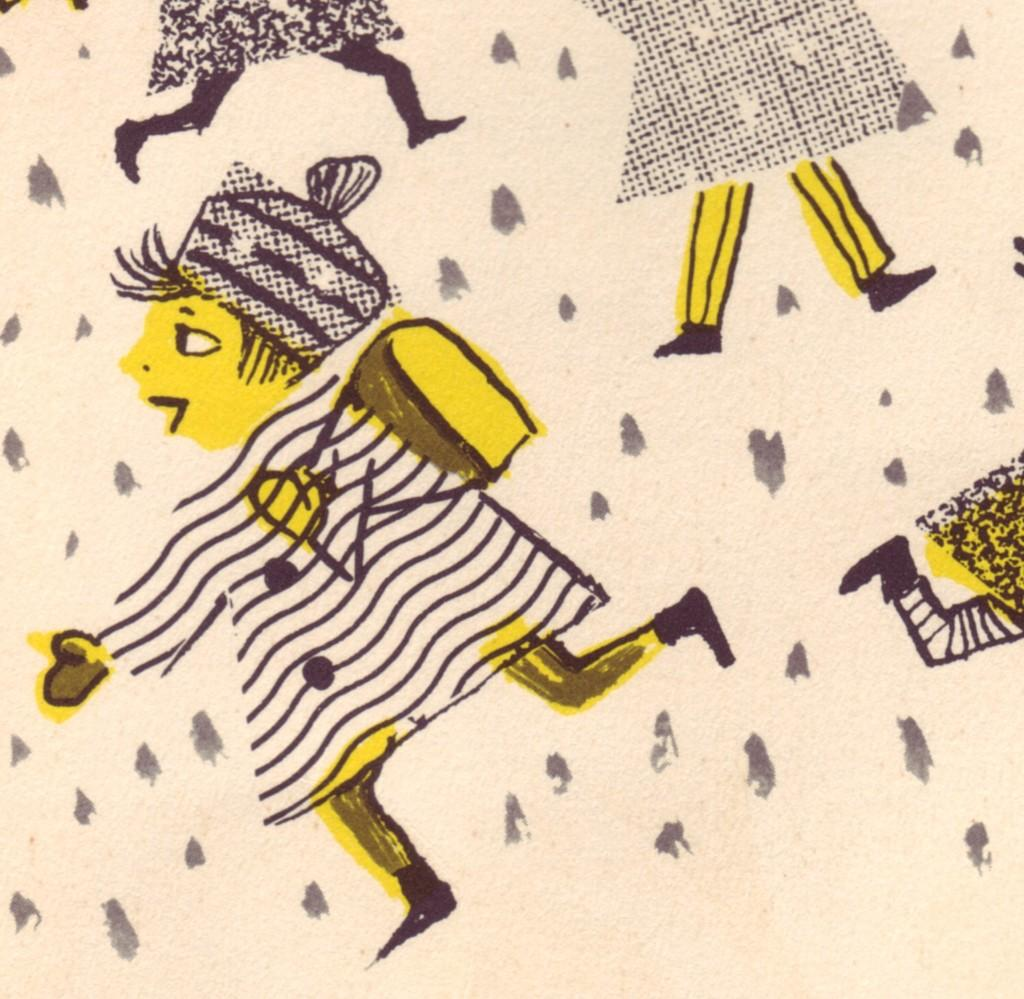What is the main subject of the image? There is a painting in the image. What can be seen in the painting? The painting contains people. What type of voice can be heard coming from the painting in the image? There is no sound or voice present in the image, as it is a painting of people. 